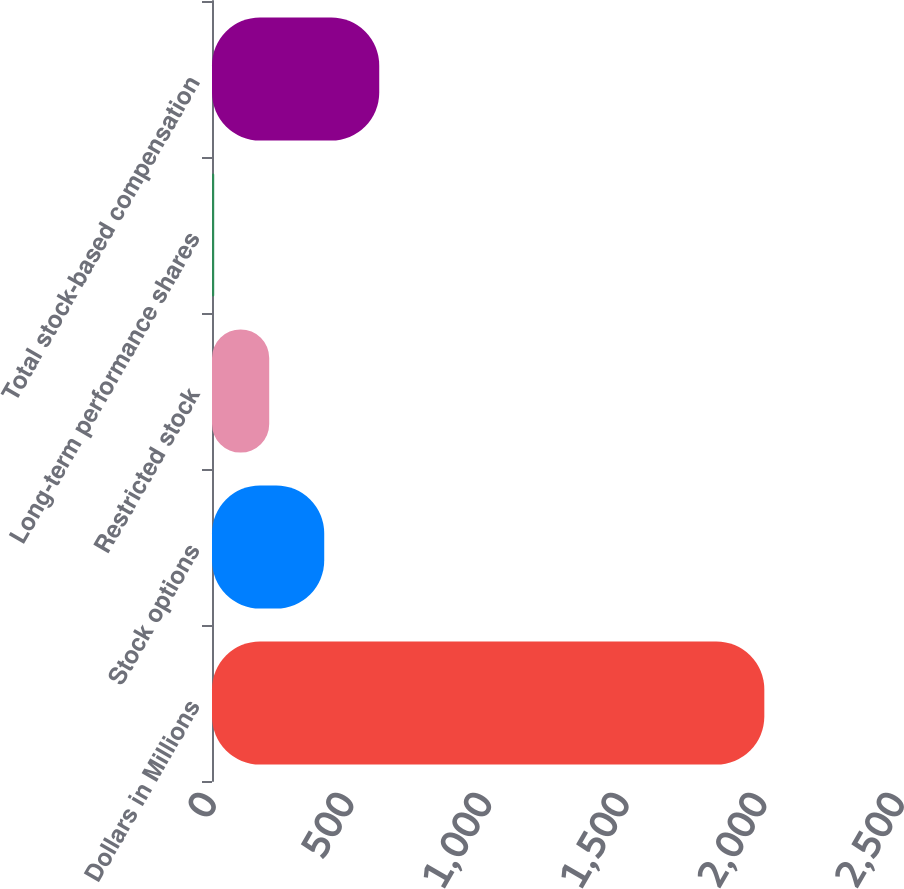Convert chart to OTSL. <chart><loc_0><loc_0><loc_500><loc_500><bar_chart><fcel>Dollars in Millions<fcel>Stock options<fcel>Restricted stock<fcel>Long-term performance shares<fcel>Total stock-based compensation<nl><fcel>2007<fcel>407.8<fcel>207.9<fcel>8<fcel>607.7<nl></chart> 